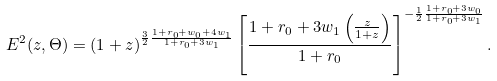Convert formula to latex. <formula><loc_0><loc_0><loc_500><loc_500>E ^ { 2 } ( z , \Theta ) = ( 1 + z ) ^ { \frac { 3 } { 2 } \frac { 1 + r _ { 0 } + w _ { 0 } + 4 w _ { 1 } } { 1 + r _ { 0 } + 3 w _ { 1 } } } \left [ \frac { 1 + r _ { 0 } + 3 w _ { 1 } \left ( \frac { z } { 1 + z } \right ) } { 1 + r _ { 0 } } \right ] ^ { - \frac { 1 } { 2 } \frac { 1 + r _ { 0 } + 3 w _ { 0 } } { 1 + r _ { 0 } + 3 w _ { 1 } } } .</formula> 